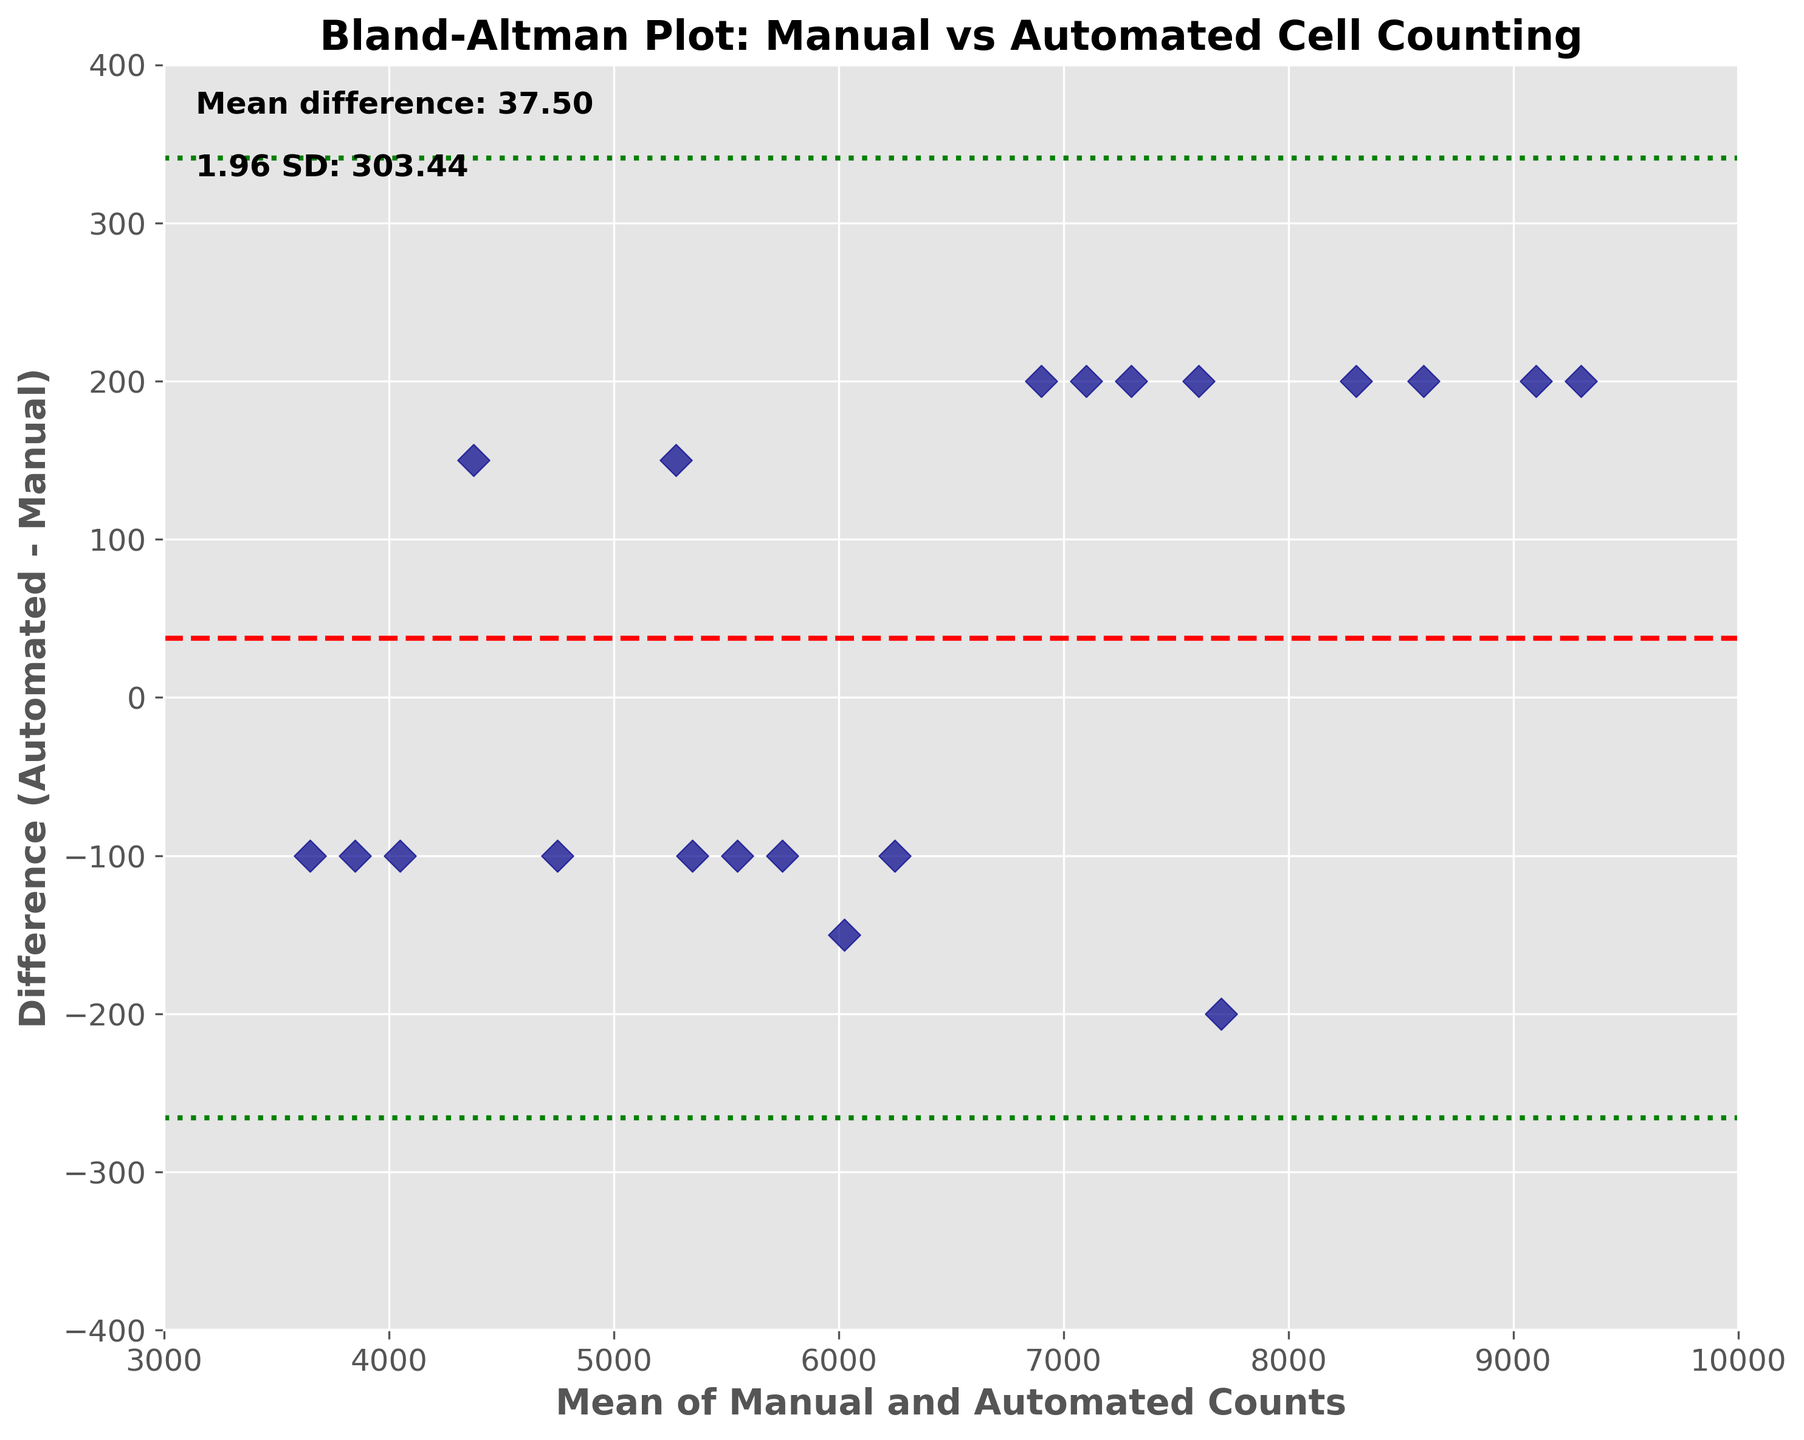How many data points are there on the plot? Count the number of individual scatter points on the plot; each represents a data point from the dataset. There are 20 data points in the dataset, so there should be 20 scatter points.
Answer: 20 What is the title of the plot? The title appears at the top of the plot. It is set to summarize what the plot represents.
Answer: Bland-Altman Plot: Manual vs Automated Cell Counting What does the red dashed line represent? This line represents the mean difference between the manual and automated counts, calculated as the average of all differences. The red color and dashed style distinguish it from other lines.
Answer: Mean difference How is the 'Mean of Manual and Automated Counts' axis labeled? This is the x-axis, and its label is provided below the axis.
Answer: Mean of Manual and Automated Counts What do the green dotted lines represent? The green dotted lines indicate the limits of agreement, calculated as the mean difference plus and minus 1.96 times the standard deviation of the differences. This is typically used to show how much the two methods can differ yet still be in agreement.
Answer: Limits of agreement What is the mean difference value? The mean difference value is usually provided next to the red dashed line within the plot. It is also noted on the plot in a text box. For accuracy, it can also be verified through the formula. In this case, the value is provided on the plot directly.
Answer: 50 If the red dashed line is the mean difference, what are the approximate values for the green dotted lines (the limits of agreement)? These values are calculated as the mean difference ± 1.96 times the standard deviation of the differences. They are also noted on the plot in a text box and indicated by the green dotted lines.
Answer: Approximately 50 ± 390 (440 and -340) How many data points fall outside the limits of agreement (green dotted lines)? Count the scatter points that fall above or below the green dotted lines, which indicate the limits of agreement.
Answer: 0 What is the maximum difference observed between automated and manual counts? Check all the scatter points and identify the one with the highest deviation on the y-axis, which represents the difference. In this data, the largest difference values are 200 and -200.
Answer: 200 How wide is the range between the limits of agreement? The range between the limits of agreement is the difference between the upper and lower green dotted lines. This can be calculated by subtracting the lower limit from the upper limit: 440 - (-340) = 780.
Answer: 780 